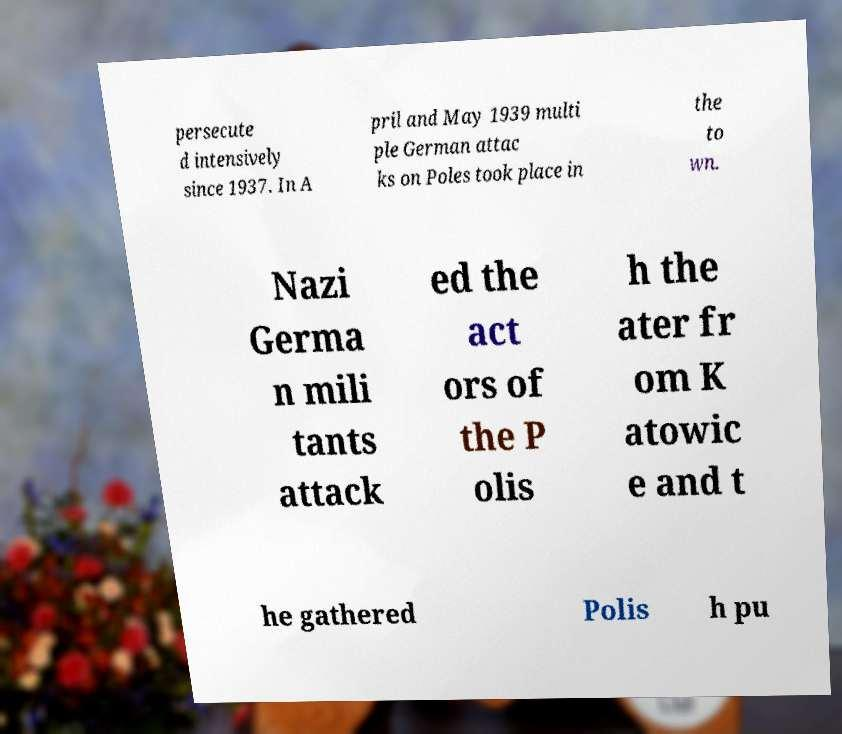Can you accurately transcribe the text from the provided image for me? persecute d intensively since 1937. In A pril and May 1939 multi ple German attac ks on Poles took place in the to wn. Nazi Germa n mili tants attack ed the act ors of the P olis h the ater fr om K atowic e and t he gathered Polis h pu 